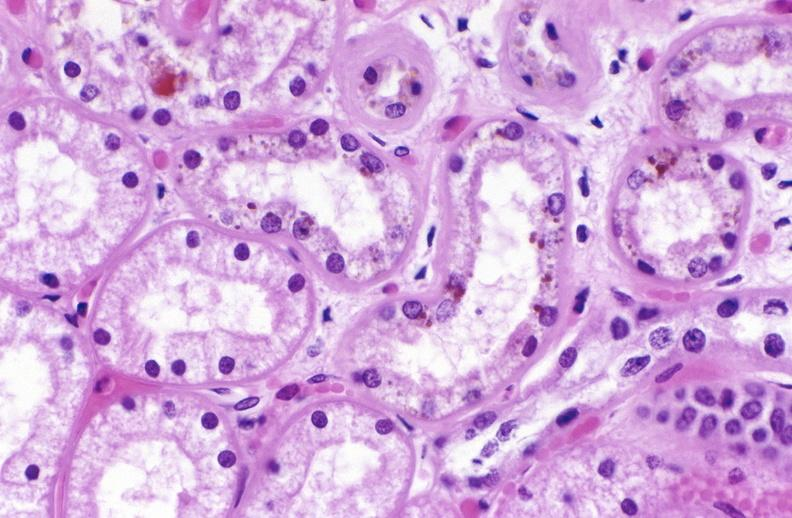where is this?
Answer the question using a single word or phrase. Urinary 